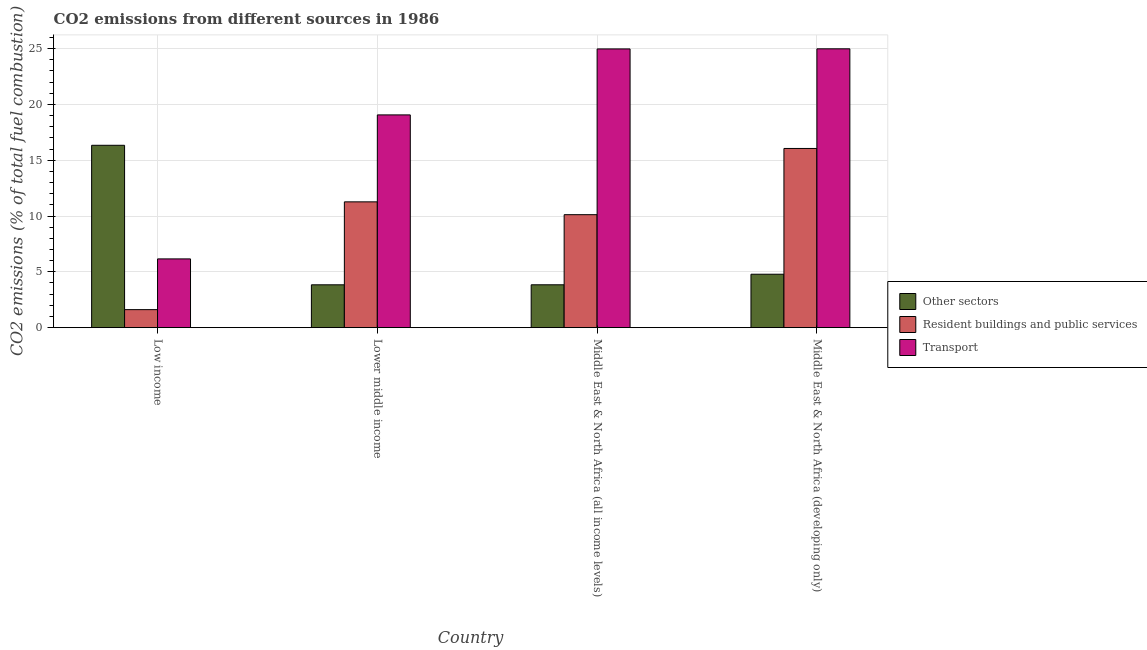How many different coloured bars are there?
Make the answer very short. 3. Are the number of bars per tick equal to the number of legend labels?
Your response must be concise. Yes. How many bars are there on the 4th tick from the left?
Make the answer very short. 3. What is the label of the 2nd group of bars from the left?
Give a very brief answer. Lower middle income. What is the percentage of co2 emissions from resident buildings and public services in Middle East & North Africa (all income levels)?
Your response must be concise. 10.12. Across all countries, what is the maximum percentage of co2 emissions from transport?
Ensure brevity in your answer.  24.97. Across all countries, what is the minimum percentage of co2 emissions from other sectors?
Give a very brief answer. 3.84. In which country was the percentage of co2 emissions from resident buildings and public services maximum?
Ensure brevity in your answer.  Middle East & North Africa (developing only). In which country was the percentage of co2 emissions from other sectors minimum?
Ensure brevity in your answer.  Lower middle income. What is the total percentage of co2 emissions from transport in the graph?
Make the answer very short. 75.15. What is the difference between the percentage of co2 emissions from transport in Low income and that in Lower middle income?
Give a very brief answer. -12.9. What is the difference between the percentage of co2 emissions from resident buildings and public services in Low income and the percentage of co2 emissions from transport in Middle East & North Africa (all income levels)?
Your answer should be compact. -23.35. What is the average percentage of co2 emissions from resident buildings and public services per country?
Your response must be concise. 9.76. What is the difference between the percentage of co2 emissions from other sectors and percentage of co2 emissions from resident buildings and public services in Middle East & North Africa (all income levels)?
Give a very brief answer. -6.28. In how many countries, is the percentage of co2 emissions from transport greater than 16 %?
Offer a terse response. 3. What is the ratio of the percentage of co2 emissions from other sectors in Low income to that in Middle East & North Africa (developing only)?
Offer a terse response. 3.41. Is the difference between the percentage of co2 emissions from transport in Low income and Middle East & North Africa (all income levels) greater than the difference between the percentage of co2 emissions from resident buildings and public services in Low income and Middle East & North Africa (all income levels)?
Your answer should be very brief. No. What is the difference between the highest and the second highest percentage of co2 emissions from resident buildings and public services?
Offer a terse response. 4.78. What is the difference between the highest and the lowest percentage of co2 emissions from transport?
Your answer should be compact. 18.81. What does the 2nd bar from the left in Lower middle income represents?
Your answer should be very brief. Resident buildings and public services. What does the 1st bar from the right in Middle East & North Africa (all income levels) represents?
Offer a very short reply. Transport. Is it the case that in every country, the sum of the percentage of co2 emissions from other sectors and percentage of co2 emissions from resident buildings and public services is greater than the percentage of co2 emissions from transport?
Your answer should be very brief. No. How many bars are there?
Offer a terse response. 12. How many countries are there in the graph?
Offer a terse response. 4. What is the difference between two consecutive major ticks on the Y-axis?
Your answer should be compact. 5. Are the values on the major ticks of Y-axis written in scientific E-notation?
Make the answer very short. No. Does the graph contain any zero values?
Offer a terse response. No. Does the graph contain grids?
Your response must be concise. Yes. Where does the legend appear in the graph?
Offer a terse response. Center right. How many legend labels are there?
Provide a short and direct response. 3. How are the legend labels stacked?
Keep it short and to the point. Vertical. What is the title of the graph?
Ensure brevity in your answer.  CO2 emissions from different sources in 1986. What is the label or title of the Y-axis?
Your response must be concise. CO2 emissions (% of total fuel combustion). What is the CO2 emissions (% of total fuel combustion) in Other sectors in Low income?
Keep it short and to the point. 16.33. What is the CO2 emissions (% of total fuel combustion) in Resident buildings and public services in Low income?
Your answer should be compact. 1.62. What is the CO2 emissions (% of total fuel combustion) in Transport in Low income?
Make the answer very short. 6.16. What is the CO2 emissions (% of total fuel combustion) of Other sectors in Lower middle income?
Your answer should be compact. 3.84. What is the CO2 emissions (% of total fuel combustion) of Resident buildings and public services in Lower middle income?
Make the answer very short. 11.27. What is the CO2 emissions (% of total fuel combustion) of Transport in Lower middle income?
Make the answer very short. 19.05. What is the CO2 emissions (% of total fuel combustion) of Other sectors in Middle East & North Africa (all income levels)?
Give a very brief answer. 3.84. What is the CO2 emissions (% of total fuel combustion) in Resident buildings and public services in Middle East & North Africa (all income levels)?
Give a very brief answer. 10.12. What is the CO2 emissions (% of total fuel combustion) in Transport in Middle East & North Africa (all income levels)?
Provide a succinct answer. 24.96. What is the CO2 emissions (% of total fuel combustion) of Other sectors in Middle East & North Africa (developing only)?
Provide a short and direct response. 4.79. What is the CO2 emissions (% of total fuel combustion) in Resident buildings and public services in Middle East & North Africa (developing only)?
Keep it short and to the point. 16.05. What is the CO2 emissions (% of total fuel combustion) of Transport in Middle East & North Africa (developing only)?
Provide a short and direct response. 24.97. Across all countries, what is the maximum CO2 emissions (% of total fuel combustion) in Other sectors?
Your response must be concise. 16.33. Across all countries, what is the maximum CO2 emissions (% of total fuel combustion) in Resident buildings and public services?
Keep it short and to the point. 16.05. Across all countries, what is the maximum CO2 emissions (% of total fuel combustion) in Transport?
Offer a terse response. 24.97. Across all countries, what is the minimum CO2 emissions (% of total fuel combustion) of Other sectors?
Your answer should be compact. 3.84. Across all countries, what is the minimum CO2 emissions (% of total fuel combustion) in Resident buildings and public services?
Make the answer very short. 1.62. Across all countries, what is the minimum CO2 emissions (% of total fuel combustion) in Transport?
Your response must be concise. 6.16. What is the total CO2 emissions (% of total fuel combustion) of Other sectors in the graph?
Provide a succinct answer. 28.8. What is the total CO2 emissions (% of total fuel combustion) of Resident buildings and public services in the graph?
Offer a very short reply. 39.05. What is the total CO2 emissions (% of total fuel combustion) in Transport in the graph?
Ensure brevity in your answer.  75.15. What is the difference between the CO2 emissions (% of total fuel combustion) in Other sectors in Low income and that in Lower middle income?
Keep it short and to the point. 12.5. What is the difference between the CO2 emissions (% of total fuel combustion) in Resident buildings and public services in Low income and that in Lower middle income?
Ensure brevity in your answer.  -9.65. What is the difference between the CO2 emissions (% of total fuel combustion) in Transport in Low income and that in Lower middle income?
Provide a short and direct response. -12.9. What is the difference between the CO2 emissions (% of total fuel combustion) of Other sectors in Low income and that in Middle East & North Africa (all income levels)?
Ensure brevity in your answer.  12.49. What is the difference between the CO2 emissions (% of total fuel combustion) of Resident buildings and public services in Low income and that in Middle East & North Africa (all income levels)?
Give a very brief answer. -8.5. What is the difference between the CO2 emissions (% of total fuel combustion) in Transport in Low income and that in Middle East & North Africa (all income levels)?
Offer a terse response. -18.8. What is the difference between the CO2 emissions (% of total fuel combustion) of Other sectors in Low income and that in Middle East & North Africa (developing only)?
Offer a terse response. 11.55. What is the difference between the CO2 emissions (% of total fuel combustion) in Resident buildings and public services in Low income and that in Middle East & North Africa (developing only)?
Make the answer very short. -14.43. What is the difference between the CO2 emissions (% of total fuel combustion) of Transport in Low income and that in Middle East & North Africa (developing only)?
Your response must be concise. -18.81. What is the difference between the CO2 emissions (% of total fuel combustion) in Other sectors in Lower middle income and that in Middle East & North Africa (all income levels)?
Provide a succinct answer. -0. What is the difference between the CO2 emissions (% of total fuel combustion) of Resident buildings and public services in Lower middle income and that in Middle East & North Africa (all income levels)?
Give a very brief answer. 1.15. What is the difference between the CO2 emissions (% of total fuel combustion) in Transport in Lower middle income and that in Middle East & North Africa (all income levels)?
Offer a terse response. -5.91. What is the difference between the CO2 emissions (% of total fuel combustion) in Other sectors in Lower middle income and that in Middle East & North Africa (developing only)?
Your answer should be compact. -0.95. What is the difference between the CO2 emissions (% of total fuel combustion) in Resident buildings and public services in Lower middle income and that in Middle East & North Africa (developing only)?
Offer a terse response. -4.78. What is the difference between the CO2 emissions (% of total fuel combustion) in Transport in Lower middle income and that in Middle East & North Africa (developing only)?
Offer a terse response. -5.92. What is the difference between the CO2 emissions (% of total fuel combustion) in Other sectors in Middle East & North Africa (all income levels) and that in Middle East & North Africa (developing only)?
Give a very brief answer. -0.95. What is the difference between the CO2 emissions (% of total fuel combustion) of Resident buildings and public services in Middle East & North Africa (all income levels) and that in Middle East & North Africa (developing only)?
Your answer should be compact. -5.93. What is the difference between the CO2 emissions (% of total fuel combustion) of Transport in Middle East & North Africa (all income levels) and that in Middle East & North Africa (developing only)?
Your response must be concise. -0.01. What is the difference between the CO2 emissions (% of total fuel combustion) of Other sectors in Low income and the CO2 emissions (% of total fuel combustion) of Resident buildings and public services in Lower middle income?
Offer a very short reply. 5.07. What is the difference between the CO2 emissions (% of total fuel combustion) of Other sectors in Low income and the CO2 emissions (% of total fuel combustion) of Transport in Lower middle income?
Make the answer very short. -2.72. What is the difference between the CO2 emissions (% of total fuel combustion) of Resident buildings and public services in Low income and the CO2 emissions (% of total fuel combustion) of Transport in Lower middle income?
Offer a very short reply. -17.44. What is the difference between the CO2 emissions (% of total fuel combustion) of Other sectors in Low income and the CO2 emissions (% of total fuel combustion) of Resident buildings and public services in Middle East & North Africa (all income levels)?
Make the answer very short. 6.21. What is the difference between the CO2 emissions (% of total fuel combustion) in Other sectors in Low income and the CO2 emissions (% of total fuel combustion) in Transport in Middle East & North Africa (all income levels)?
Offer a very short reply. -8.63. What is the difference between the CO2 emissions (% of total fuel combustion) in Resident buildings and public services in Low income and the CO2 emissions (% of total fuel combustion) in Transport in Middle East & North Africa (all income levels)?
Ensure brevity in your answer.  -23.35. What is the difference between the CO2 emissions (% of total fuel combustion) in Other sectors in Low income and the CO2 emissions (% of total fuel combustion) in Resident buildings and public services in Middle East & North Africa (developing only)?
Your response must be concise. 0.28. What is the difference between the CO2 emissions (% of total fuel combustion) of Other sectors in Low income and the CO2 emissions (% of total fuel combustion) of Transport in Middle East & North Africa (developing only)?
Give a very brief answer. -8.64. What is the difference between the CO2 emissions (% of total fuel combustion) of Resident buildings and public services in Low income and the CO2 emissions (% of total fuel combustion) of Transport in Middle East & North Africa (developing only)?
Provide a succinct answer. -23.36. What is the difference between the CO2 emissions (% of total fuel combustion) of Other sectors in Lower middle income and the CO2 emissions (% of total fuel combustion) of Resident buildings and public services in Middle East & North Africa (all income levels)?
Offer a very short reply. -6.28. What is the difference between the CO2 emissions (% of total fuel combustion) in Other sectors in Lower middle income and the CO2 emissions (% of total fuel combustion) in Transport in Middle East & North Africa (all income levels)?
Provide a short and direct response. -21.12. What is the difference between the CO2 emissions (% of total fuel combustion) in Resident buildings and public services in Lower middle income and the CO2 emissions (% of total fuel combustion) in Transport in Middle East & North Africa (all income levels)?
Offer a terse response. -13.69. What is the difference between the CO2 emissions (% of total fuel combustion) in Other sectors in Lower middle income and the CO2 emissions (% of total fuel combustion) in Resident buildings and public services in Middle East & North Africa (developing only)?
Your answer should be compact. -12.21. What is the difference between the CO2 emissions (% of total fuel combustion) of Other sectors in Lower middle income and the CO2 emissions (% of total fuel combustion) of Transport in Middle East & North Africa (developing only)?
Offer a very short reply. -21.13. What is the difference between the CO2 emissions (% of total fuel combustion) in Resident buildings and public services in Lower middle income and the CO2 emissions (% of total fuel combustion) in Transport in Middle East & North Africa (developing only)?
Keep it short and to the point. -13.71. What is the difference between the CO2 emissions (% of total fuel combustion) in Other sectors in Middle East & North Africa (all income levels) and the CO2 emissions (% of total fuel combustion) in Resident buildings and public services in Middle East & North Africa (developing only)?
Your answer should be compact. -12.21. What is the difference between the CO2 emissions (% of total fuel combustion) of Other sectors in Middle East & North Africa (all income levels) and the CO2 emissions (% of total fuel combustion) of Transport in Middle East & North Africa (developing only)?
Offer a very short reply. -21.13. What is the difference between the CO2 emissions (% of total fuel combustion) in Resident buildings and public services in Middle East & North Africa (all income levels) and the CO2 emissions (% of total fuel combustion) in Transport in Middle East & North Africa (developing only)?
Your response must be concise. -14.85. What is the average CO2 emissions (% of total fuel combustion) of Other sectors per country?
Offer a very short reply. 7.2. What is the average CO2 emissions (% of total fuel combustion) of Resident buildings and public services per country?
Your answer should be compact. 9.76. What is the average CO2 emissions (% of total fuel combustion) of Transport per country?
Offer a terse response. 18.79. What is the difference between the CO2 emissions (% of total fuel combustion) in Other sectors and CO2 emissions (% of total fuel combustion) in Resident buildings and public services in Low income?
Provide a succinct answer. 14.72. What is the difference between the CO2 emissions (% of total fuel combustion) in Other sectors and CO2 emissions (% of total fuel combustion) in Transport in Low income?
Ensure brevity in your answer.  10.18. What is the difference between the CO2 emissions (% of total fuel combustion) in Resident buildings and public services and CO2 emissions (% of total fuel combustion) in Transport in Low income?
Make the answer very short. -4.54. What is the difference between the CO2 emissions (% of total fuel combustion) in Other sectors and CO2 emissions (% of total fuel combustion) in Resident buildings and public services in Lower middle income?
Your answer should be compact. -7.43. What is the difference between the CO2 emissions (% of total fuel combustion) in Other sectors and CO2 emissions (% of total fuel combustion) in Transport in Lower middle income?
Keep it short and to the point. -15.22. What is the difference between the CO2 emissions (% of total fuel combustion) of Resident buildings and public services and CO2 emissions (% of total fuel combustion) of Transport in Lower middle income?
Offer a terse response. -7.79. What is the difference between the CO2 emissions (% of total fuel combustion) in Other sectors and CO2 emissions (% of total fuel combustion) in Resident buildings and public services in Middle East & North Africa (all income levels)?
Keep it short and to the point. -6.28. What is the difference between the CO2 emissions (% of total fuel combustion) of Other sectors and CO2 emissions (% of total fuel combustion) of Transport in Middle East & North Africa (all income levels)?
Your answer should be compact. -21.12. What is the difference between the CO2 emissions (% of total fuel combustion) of Resident buildings and public services and CO2 emissions (% of total fuel combustion) of Transport in Middle East & North Africa (all income levels)?
Provide a short and direct response. -14.84. What is the difference between the CO2 emissions (% of total fuel combustion) in Other sectors and CO2 emissions (% of total fuel combustion) in Resident buildings and public services in Middle East & North Africa (developing only)?
Give a very brief answer. -11.26. What is the difference between the CO2 emissions (% of total fuel combustion) of Other sectors and CO2 emissions (% of total fuel combustion) of Transport in Middle East & North Africa (developing only)?
Make the answer very short. -20.19. What is the difference between the CO2 emissions (% of total fuel combustion) in Resident buildings and public services and CO2 emissions (% of total fuel combustion) in Transport in Middle East & North Africa (developing only)?
Ensure brevity in your answer.  -8.92. What is the ratio of the CO2 emissions (% of total fuel combustion) in Other sectors in Low income to that in Lower middle income?
Your answer should be very brief. 4.26. What is the ratio of the CO2 emissions (% of total fuel combustion) in Resident buildings and public services in Low income to that in Lower middle income?
Provide a succinct answer. 0.14. What is the ratio of the CO2 emissions (% of total fuel combustion) in Transport in Low income to that in Lower middle income?
Keep it short and to the point. 0.32. What is the ratio of the CO2 emissions (% of total fuel combustion) of Other sectors in Low income to that in Middle East & North Africa (all income levels)?
Ensure brevity in your answer.  4.25. What is the ratio of the CO2 emissions (% of total fuel combustion) in Resident buildings and public services in Low income to that in Middle East & North Africa (all income levels)?
Provide a succinct answer. 0.16. What is the ratio of the CO2 emissions (% of total fuel combustion) of Transport in Low income to that in Middle East & North Africa (all income levels)?
Your answer should be very brief. 0.25. What is the ratio of the CO2 emissions (% of total fuel combustion) in Other sectors in Low income to that in Middle East & North Africa (developing only)?
Keep it short and to the point. 3.41. What is the ratio of the CO2 emissions (% of total fuel combustion) in Resident buildings and public services in Low income to that in Middle East & North Africa (developing only)?
Offer a very short reply. 0.1. What is the ratio of the CO2 emissions (% of total fuel combustion) of Transport in Low income to that in Middle East & North Africa (developing only)?
Keep it short and to the point. 0.25. What is the ratio of the CO2 emissions (% of total fuel combustion) of Other sectors in Lower middle income to that in Middle East & North Africa (all income levels)?
Offer a very short reply. 1. What is the ratio of the CO2 emissions (% of total fuel combustion) in Resident buildings and public services in Lower middle income to that in Middle East & North Africa (all income levels)?
Provide a short and direct response. 1.11. What is the ratio of the CO2 emissions (% of total fuel combustion) in Transport in Lower middle income to that in Middle East & North Africa (all income levels)?
Offer a terse response. 0.76. What is the ratio of the CO2 emissions (% of total fuel combustion) in Other sectors in Lower middle income to that in Middle East & North Africa (developing only)?
Make the answer very short. 0.8. What is the ratio of the CO2 emissions (% of total fuel combustion) in Resident buildings and public services in Lower middle income to that in Middle East & North Africa (developing only)?
Keep it short and to the point. 0.7. What is the ratio of the CO2 emissions (% of total fuel combustion) of Transport in Lower middle income to that in Middle East & North Africa (developing only)?
Your answer should be compact. 0.76. What is the ratio of the CO2 emissions (% of total fuel combustion) in Other sectors in Middle East & North Africa (all income levels) to that in Middle East & North Africa (developing only)?
Give a very brief answer. 0.8. What is the ratio of the CO2 emissions (% of total fuel combustion) of Resident buildings and public services in Middle East & North Africa (all income levels) to that in Middle East & North Africa (developing only)?
Your response must be concise. 0.63. What is the difference between the highest and the second highest CO2 emissions (% of total fuel combustion) of Other sectors?
Ensure brevity in your answer.  11.55. What is the difference between the highest and the second highest CO2 emissions (% of total fuel combustion) in Resident buildings and public services?
Make the answer very short. 4.78. What is the difference between the highest and the second highest CO2 emissions (% of total fuel combustion) of Transport?
Offer a terse response. 0.01. What is the difference between the highest and the lowest CO2 emissions (% of total fuel combustion) of Other sectors?
Your answer should be very brief. 12.5. What is the difference between the highest and the lowest CO2 emissions (% of total fuel combustion) in Resident buildings and public services?
Provide a succinct answer. 14.43. What is the difference between the highest and the lowest CO2 emissions (% of total fuel combustion) in Transport?
Your answer should be very brief. 18.81. 